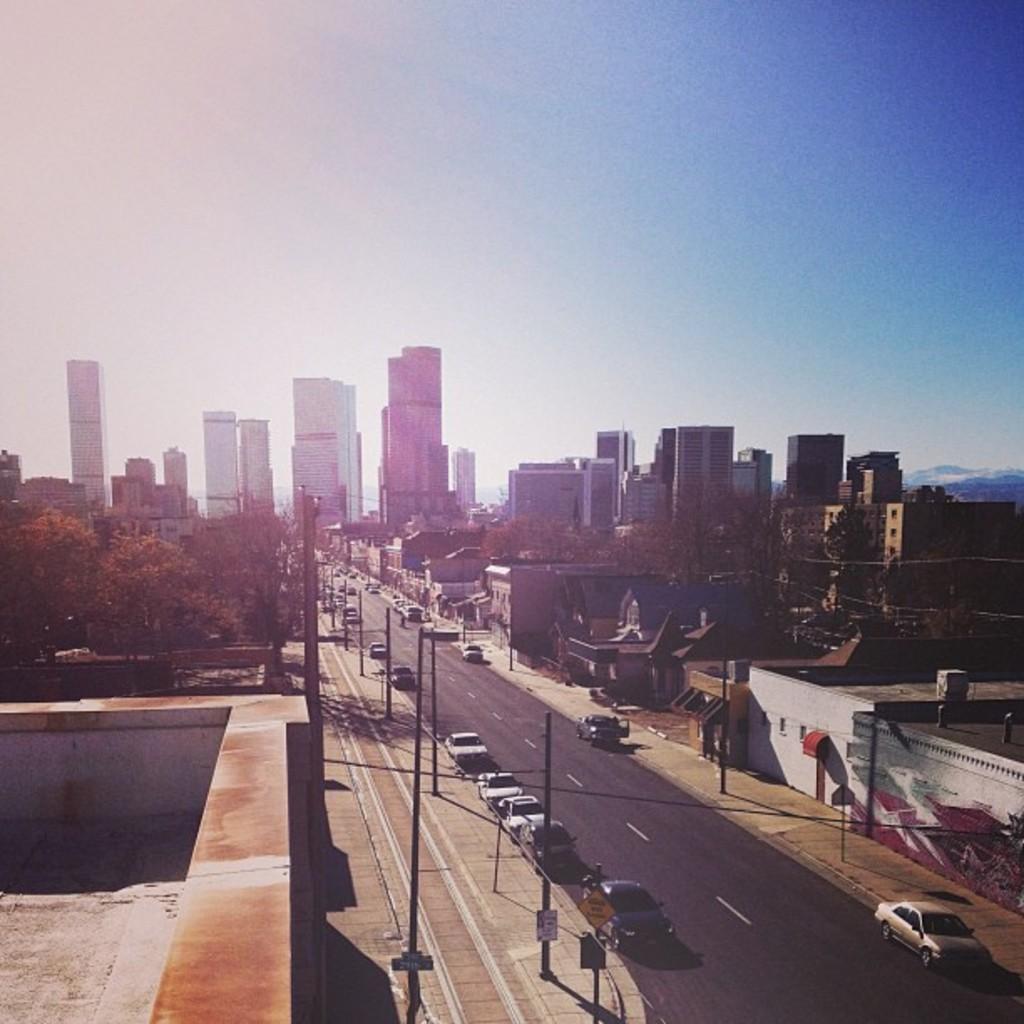Could you give a brief overview of what you see in this image? This is an outside view. On the right side there is a road and I can see many cars on the road. On both sides of the road there are some poles. In the background, I can see the buildings and trees. At the top of the image I can see the sky. 